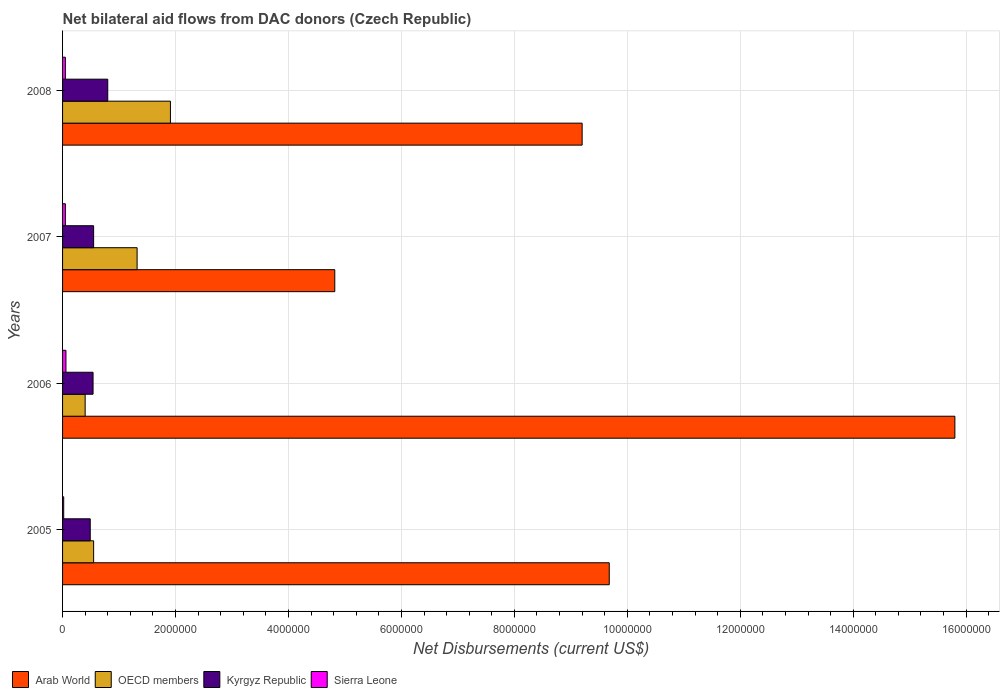How many different coloured bars are there?
Offer a terse response. 4. How many groups of bars are there?
Your answer should be compact. 4. Are the number of bars per tick equal to the number of legend labels?
Your answer should be compact. Yes. How many bars are there on the 4th tick from the top?
Provide a succinct answer. 4. How many bars are there on the 2nd tick from the bottom?
Your answer should be very brief. 4. In how many cases, is the number of bars for a given year not equal to the number of legend labels?
Keep it short and to the point. 0. What is the net bilateral aid flows in OECD members in 2007?
Provide a succinct answer. 1.32e+06. Across all years, what is the maximum net bilateral aid flows in Sierra Leone?
Your answer should be very brief. 6.00e+04. Across all years, what is the minimum net bilateral aid flows in OECD members?
Your answer should be compact. 4.00e+05. What is the total net bilateral aid flows in Kyrgyz Republic in the graph?
Provide a succinct answer. 2.38e+06. What is the difference between the net bilateral aid flows in Kyrgyz Republic in 2005 and that in 2007?
Your response must be concise. -6.00e+04. What is the difference between the net bilateral aid flows in Arab World in 2008 and the net bilateral aid flows in OECD members in 2007?
Your answer should be compact. 7.88e+06. What is the average net bilateral aid flows in Arab World per year?
Provide a short and direct response. 9.88e+06. In the year 2005, what is the difference between the net bilateral aid flows in Arab World and net bilateral aid flows in Sierra Leone?
Ensure brevity in your answer.  9.66e+06. In how many years, is the net bilateral aid flows in Sierra Leone greater than 11200000 US$?
Offer a terse response. 0. What is the ratio of the net bilateral aid flows in Sierra Leone in 2005 to that in 2006?
Offer a terse response. 0.33. What is the difference between the highest and the second highest net bilateral aid flows in Sierra Leone?
Give a very brief answer. 10000. What is the difference between the highest and the lowest net bilateral aid flows in Arab World?
Your answer should be very brief. 1.10e+07. In how many years, is the net bilateral aid flows in Arab World greater than the average net bilateral aid flows in Arab World taken over all years?
Your answer should be compact. 1. Is the sum of the net bilateral aid flows in Sierra Leone in 2006 and 2008 greater than the maximum net bilateral aid flows in OECD members across all years?
Provide a succinct answer. No. What does the 4th bar from the top in 2005 represents?
Offer a terse response. Arab World. What does the 4th bar from the bottom in 2006 represents?
Make the answer very short. Sierra Leone. Is it the case that in every year, the sum of the net bilateral aid flows in Kyrgyz Republic and net bilateral aid flows in OECD members is greater than the net bilateral aid flows in Sierra Leone?
Offer a terse response. Yes. How many bars are there?
Ensure brevity in your answer.  16. Are all the bars in the graph horizontal?
Make the answer very short. Yes. What is the difference between two consecutive major ticks on the X-axis?
Offer a very short reply. 2.00e+06. Are the values on the major ticks of X-axis written in scientific E-notation?
Keep it short and to the point. No. How are the legend labels stacked?
Keep it short and to the point. Horizontal. What is the title of the graph?
Provide a short and direct response. Net bilateral aid flows from DAC donors (Czech Republic). Does "Haiti" appear as one of the legend labels in the graph?
Your answer should be compact. No. What is the label or title of the X-axis?
Give a very brief answer. Net Disbursements (current US$). What is the Net Disbursements (current US$) of Arab World in 2005?
Offer a terse response. 9.68e+06. What is the Net Disbursements (current US$) of OECD members in 2005?
Make the answer very short. 5.50e+05. What is the Net Disbursements (current US$) of Arab World in 2006?
Offer a terse response. 1.58e+07. What is the Net Disbursements (current US$) in Kyrgyz Republic in 2006?
Your answer should be compact. 5.40e+05. What is the Net Disbursements (current US$) in Sierra Leone in 2006?
Offer a very short reply. 6.00e+04. What is the Net Disbursements (current US$) in Arab World in 2007?
Your response must be concise. 4.82e+06. What is the Net Disbursements (current US$) in OECD members in 2007?
Keep it short and to the point. 1.32e+06. What is the Net Disbursements (current US$) of Sierra Leone in 2007?
Your response must be concise. 5.00e+04. What is the Net Disbursements (current US$) of Arab World in 2008?
Provide a short and direct response. 9.20e+06. What is the Net Disbursements (current US$) of OECD members in 2008?
Your answer should be compact. 1.91e+06. What is the Net Disbursements (current US$) of Sierra Leone in 2008?
Provide a short and direct response. 5.00e+04. Across all years, what is the maximum Net Disbursements (current US$) of Arab World?
Offer a terse response. 1.58e+07. Across all years, what is the maximum Net Disbursements (current US$) in OECD members?
Ensure brevity in your answer.  1.91e+06. Across all years, what is the maximum Net Disbursements (current US$) in Kyrgyz Republic?
Provide a succinct answer. 8.00e+05. Across all years, what is the maximum Net Disbursements (current US$) in Sierra Leone?
Your response must be concise. 6.00e+04. Across all years, what is the minimum Net Disbursements (current US$) of Arab World?
Provide a short and direct response. 4.82e+06. What is the total Net Disbursements (current US$) in Arab World in the graph?
Your answer should be very brief. 3.95e+07. What is the total Net Disbursements (current US$) in OECD members in the graph?
Your answer should be compact. 4.18e+06. What is the total Net Disbursements (current US$) in Kyrgyz Republic in the graph?
Your response must be concise. 2.38e+06. What is the total Net Disbursements (current US$) of Sierra Leone in the graph?
Your response must be concise. 1.80e+05. What is the difference between the Net Disbursements (current US$) of Arab World in 2005 and that in 2006?
Provide a succinct answer. -6.12e+06. What is the difference between the Net Disbursements (current US$) of OECD members in 2005 and that in 2006?
Provide a short and direct response. 1.50e+05. What is the difference between the Net Disbursements (current US$) in Arab World in 2005 and that in 2007?
Offer a terse response. 4.86e+06. What is the difference between the Net Disbursements (current US$) in OECD members in 2005 and that in 2007?
Make the answer very short. -7.70e+05. What is the difference between the Net Disbursements (current US$) in OECD members in 2005 and that in 2008?
Your answer should be very brief. -1.36e+06. What is the difference between the Net Disbursements (current US$) in Kyrgyz Republic in 2005 and that in 2008?
Offer a terse response. -3.10e+05. What is the difference between the Net Disbursements (current US$) of Arab World in 2006 and that in 2007?
Your response must be concise. 1.10e+07. What is the difference between the Net Disbursements (current US$) of OECD members in 2006 and that in 2007?
Keep it short and to the point. -9.20e+05. What is the difference between the Net Disbursements (current US$) of Arab World in 2006 and that in 2008?
Offer a very short reply. 6.60e+06. What is the difference between the Net Disbursements (current US$) of OECD members in 2006 and that in 2008?
Provide a short and direct response. -1.51e+06. What is the difference between the Net Disbursements (current US$) in Arab World in 2007 and that in 2008?
Offer a terse response. -4.38e+06. What is the difference between the Net Disbursements (current US$) of OECD members in 2007 and that in 2008?
Provide a short and direct response. -5.90e+05. What is the difference between the Net Disbursements (current US$) in Kyrgyz Republic in 2007 and that in 2008?
Offer a terse response. -2.50e+05. What is the difference between the Net Disbursements (current US$) of Arab World in 2005 and the Net Disbursements (current US$) of OECD members in 2006?
Your response must be concise. 9.28e+06. What is the difference between the Net Disbursements (current US$) in Arab World in 2005 and the Net Disbursements (current US$) in Kyrgyz Republic in 2006?
Provide a succinct answer. 9.14e+06. What is the difference between the Net Disbursements (current US$) in Arab World in 2005 and the Net Disbursements (current US$) in Sierra Leone in 2006?
Make the answer very short. 9.62e+06. What is the difference between the Net Disbursements (current US$) of Kyrgyz Republic in 2005 and the Net Disbursements (current US$) of Sierra Leone in 2006?
Your response must be concise. 4.30e+05. What is the difference between the Net Disbursements (current US$) in Arab World in 2005 and the Net Disbursements (current US$) in OECD members in 2007?
Keep it short and to the point. 8.36e+06. What is the difference between the Net Disbursements (current US$) in Arab World in 2005 and the Net Disbursements (current US$) in Kyrgyz Republic in 2007?
Your response must be concise. 9.13e+06. What is the difference between the Net Disbursements (current US$) in Arab World in 2005 and the Net Disbursements (current US$) in Sierra Leone in 2007?
Offer a terse response. 9.63e+06. What is the difference between the Net Disbursements (current US$) of Arab World in 2005 and the Net Disbursements (current US$) of OECD members in 2008?
Offer a terse response. 7.77e+06. What is the difference between the Net Disbursements (current US$) of Arab World in 2005 and the Net Disbursements (current US$) of Kyrgyz Republic in 2008?
Your answer should be compact. 8.88e+06. What is the difference between the Net Disbursements (current US$) of Arab World in 2005 and the Net Disbursements (current US$) of Sierra Leone in 2008?
Give a very brief answer. 9.63e+06. What is the difference between the Net Disbursements (current US$) of Arab World in 2006 and the Net Disbursements (current US$) of OECD members in 2007?
Provide a succinct answer. 1.45e+07. What is the difference between the Net Disbursements (current US$) in Arab World in 2006 and the Net Disbursements (current US$) in Kyrgyz Republic in 2007?
Your answer should be compact. 1.52e+07. What is the difference between the Net Disbursements (current US$) of Arab World in 2006 and the Net Disbursements (current US$) of Sierra Leone in 2007?
Offer a very short reply. 1.58e+07. What is the difference between the Net Disbursements (current US$) in OECD members in 2006 and the Net Disbursements (current US$) in Kyrgyz Republic in 2007?
Ensure brevity in your answer.  -1.50e+05. What is the difference between the Net Disbursements (current US$) in Kyrgyz Republic in 2006 and the Net Disbursements (current US$) in Sierra Leone in 2007?
Your answer should be very brief. 4.90e+05. What is the difference between the Net Disbursements (current US$) of Arab World in 2006 and the Net Disbursements (current US$) of OECD members in 2008?
Offer a terse response. 1.39e+07. What is the difference between the Net Disbursements (current US$) in Arab World in 2006 and the Net Disbursements (current US$) in Kyrgyz Republic in 2008?
Provide a short and direct response. 1.50e+07. What is the difference between the Net Disbursements (current US$) of Arab World in 2006 and the Net Disbursements (current US$) of Sierra Leone in 2008?
Ensure brevity in your answer.  1.58e+07. What is the difference between the Net Disbursements (current US$) of OECD members in 2006 and the Net Disbursements (current US$) of Kyrgyz Republic in 2008?
Your response must be concise. -4.00e+05. What is the difference between the Net Disbursements (current US$) in OECD members in 2006 and the Net Disbursements (current US$) in Sierra Leone in 2008?
Provide a succinct answer. 3.50e+05. What is the difference between the Net Disbursements (current US$) in Kyrgyz Republic in 2006 and the Net Disbursements (current US$) in Sierra Leone in 2008?
Give a very brief answer. 4.90e+05. What is the difference between the Net Disbursements (current US$) in Arab World in 2007 and the Net Disbursements (current US$) in OECD members in 2008?
Give a very brief answer. 2.91e+06. What is the difference between the Net Disbursements (current US$) in Arab World in 2007 and the Net Disbursements (current US$) in Kyrgyz Republic in 2008?
Your answer should be very brief. 4.02e+06. What is the difference between the Net Disbursements (current US$) of Arab World in 2007 and the Net Disbursements (current US$) of Sierra Leone in 2008?
Your answer should be very brief. 4.77e+06. What is the difference between the Net Disbursements (current US$) of OECD members in 2007 and the Net Disbursements (current US$) of Kyrgyz Republic in 2008?
Your answer should be very brief. 5.20e+05. What is the difference between the Net Disbursements (current US$) in OECD members in 2007 and the Net Disbursements (current US$) in Sierra Leone in 2008?
Ensure brevity in your answer.  1.27e+06. What is the average Net Disbursements (current US$) of Arab World per year?
Give a very brief answer. 9.88e+06. What is the average Net Disbursements (current US$) in OECD members per year?
Your answer should be very brief. 1.04e+06. What is the average Net Disbursements (current US$) in Kyrgyz Republic per year?
Your answer should be very brief. 5.95e+05. What is the average Net Disbursements (current US$) of Sierra Leone per year?
Make the answer very short. 4.50e+04. In the year 2005, what is the difference between the Net Disbursements (current US$) of Arab World and Net Disbursements (current US$) of OECD members?
Give a very brief answer. 9.13e+06. In the year 2005, what is the difference between the Net Disbursements (current US$) of Arab World and Net Disbursements (current US$) of Kyrgyz Republic?
Make the answer very short. 9.19e+06. In the year 2005, what is the difference between the Net Disbursements (current US$) of Arab World and Net Disbursements (current US$) of Sierra Leone?
Provide a short and direct response. 9.66e+06. In the year 2005, what is the difference between the Net Disbursements (current US$) of OECD members and Net Disbursements (current US$) of Sierra Leone?
Give a very brief answer. 5.30e+05. In the year 2006, what is the difference between the Net Disbursements (current US$) in Arab World and Net Disbursements (current US$) in OECD members?
Give a very brief answer. 1.54e+07. In the year 2006, what is the difference between the Net Disbursements (current US$) of Arab World and Net Disbursements (current US$) of Kyrgyz Republic?
Ensure brevity in your answer.  1.53e+07. In the year 2006, what is the difference between the Net Disbursements (current US$) of Arab World and Net Disbursements (current US$) of Sierra Leone?
Ensure brevity in your answer.  1.57e+07. In the year 2006, what is the difference between the Net Disbursements (current US$) in OECD members and Net Disbursements (current US$) in Sierra Leone?
Your answer should be very brief. 3.40e+05. In the year 2007, what is the difference between the Net Disbursements (current US$) in Arab World and Net Disbursements (current US$) in OECD members?
Offer a terse response. 3.50e+06. In the year 2007, what is the difference between the Net Disbursements (current US$) of Arab World and Net Disbursements (current US$) of Kyrgyz Republic?
Your answer should be very brief. 4.27e+06. In the year 2007, what is the difference between the Net Disbursements (current US$) of Arab World and Net Disbursements (current US$) of Sierra Leone?
Provide a short and direct response. 4.77e+06. In the year 2007, what is the difference between the Net Disbursements (current US$) of OECD members and Net Disbursements (current US$) of Kyrgyz Republic?
Your answer should be very brief. 7.70e+05. In the year 2007, what is the difference between the Net Disbursements (current US$) in OECD members and Net Disbursements (current US$) in Sierra Leone?
Make the answer very short. 1.27e+06. In the year 2008, what is the difference between the Net Disbursements (current US$) in Arab World and Net Disbursements (current US$) in OECD members?
Your answer should be very brief. 7.29e+06. In the year 2008, what is the difference between the Net Disbursements (current US$) in Arab World and Net Disbursements (current US$) in Kyrgyz Republic?
Make the answer very short. 8.40e+06. In the year 2008, what is the difference between the Net Disbursements (current US$) of Arab World and Net Disbursements (current US$) of Sierra Leone?
Ensure brevity in your answer.  9.15e+06. In the year 2008, what is the difference between the Net Disbursements (current US$) in OECD members and Net Disbursements (current US$) in Kyrgyz Republic?
Offer a terse response. 1.11e+06. In the year 2008, what is the difference between the Net Disbursements (current US$) of OECD members and Net Disbursements (current US$) of Sierra Leone?
Keep it short and to the point. 1.86e+06. In the year 2008, what is the difference between the Net Disbursements (current US$) of Kyrgyz Republic and Net Disbursements (current US$) of Sierra Leone?
Offer a terse response. 7.50e+05. What is the ratio of the Net Disbursements (current US$) of Arab World in 2005 to that in 2006?
Offer a terse response. 0.61. What is the ratio of the Net Disbursements (current US$) of OECD members in 2005 to that in 2006?
Ensure brevity in your answer.  1.38. What is the ratio of the Net Disbursements (current US$) of Kyrgyz Republic in 2005 to that in 2006?
Provide a short and direct response. 0.91. What is the ratio of the Net Disbursements (current US$) in Sierra Leone in 2005 to that in 2006?
Provide a short and direct response. 0.33. What is the ratio of the Net Disbursements (current US$) of Arab World in 2005 to that in 2007?
Keep it short and to the point. 2.01. What is the ratio of the Net Disbursements (current US$) in OECD members in 2005 to that in 2007?
Keep it short and to the point. 0.42. What is the ratio of the Net Disbursements (current US$) in Kyrgyz Republic in 2005 to that in 2007?
Provide a short and direct response. 0.89. What is the ratio of the Net Disbursements (current US$) in Sierra Leone in 2005 to that in 2007?
Your answer should be very brief. 0.4. What is the ratio of the Net Disbursements (current US$) in Arab World in 2005 to that in 2008?
Keep it short and to the point. 1.05. What is the ratio of the Net Disbursements (current US$) in OECD members in 2005 to that in 2008?
Provide a succinct answer. 0.29. What is the ratio of the Net Disbursements (current US$) in Kyrgyz Republic in 2005 to that in 2008?
Give a very brief answer. 0.61. What is the ratio of the Net Disbursements (current US$) in Sierra Leone in 2005 to that in 2008?
Offer a terse response. 0.4. What is the ratio of the Net Disbursements (current US$) in Arab World in 2006 to that in 2007?
Provide a short and direct response. 3.28. What is the ratio of the Net Disbursements (current US$) of OECD members in 2006 to that in 2007?
Keep it short and to the point. 0.3. What is the ratio of the Net Disbursements (current US$) of Kyrgyz Republic in 2006 to that in 2007?
Provide a short and direct response. 0.98. What is the ratio of the Net Disbursements (current US$) of Arab World in 2006 to that in 2008?
Your response must be concise. 1.72. What is the ratio of the Net Disbursements (current US$) of OECD members in 2006 to that in 2008?
Provide a short and direct response. 0.21. What is the ratio of the Net Disbursements (current US$) in Kyrgyz Republic in 2006 to that in 2008?
Provide a short and direct response. 0.68. What is the ratio of the Net Disbursements (current US$) in Arab World in 2007 to that in 2008?
Offer a very short reply. 0.52. What is the ratio of the Net Disbursements (current US$) of OECD members in 2007 to that in 2008?
Provide a short and direct response. 0.69. What is the ratio of the Net Disbursements (current US$) in Kyrgyz Republic in 2007 to that in 2008?
Your response must be concise. 0.69. What is the ratio of the Net Disbursements (current US$) of Sierra Leone in 2007 to that in 2008?
Your response must be concise. 1. What is the difference between the highest and the second highest Net Disbursements (current US$) of Arab World?
Provide a short and direct response. 6.12e+06. What is the difference between the highest and the second highest Net Disbursements (current US$) in OECD members?
Provide a succinct answer. 5.90e+05. What is the difference between the highest and the lowest Net Disbursements (current US$) in Arab World?
Your answer should be compact. 1.10e+07. What is the difference between the highest and the lowest Net Disbursements (current US$) of OECD members?
Keep it short and to the point. 1.51e+06. What is the difference between the highest and the lowest Net Disbursements (current US$) of Sierra Leone?
Provide a succinct answer. 4.00e+04. 